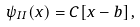<formula> <loc_0><loc_0><loc_500><loc_500>\psi _ { I I } ( x ) = C [ x - b ] \, ,</formula> 